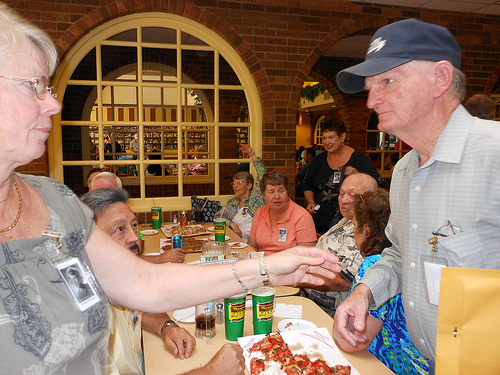<image>
Can you confirm if the man is to the right of the lady? Yes. From this viewpoint, the man is positioned to the right side relative to the lady. Where is the lady in relation to the man? Is it in front of the man? Yes. The lady is positioned in front of the man, appearing closer to the camera viewpoint. 